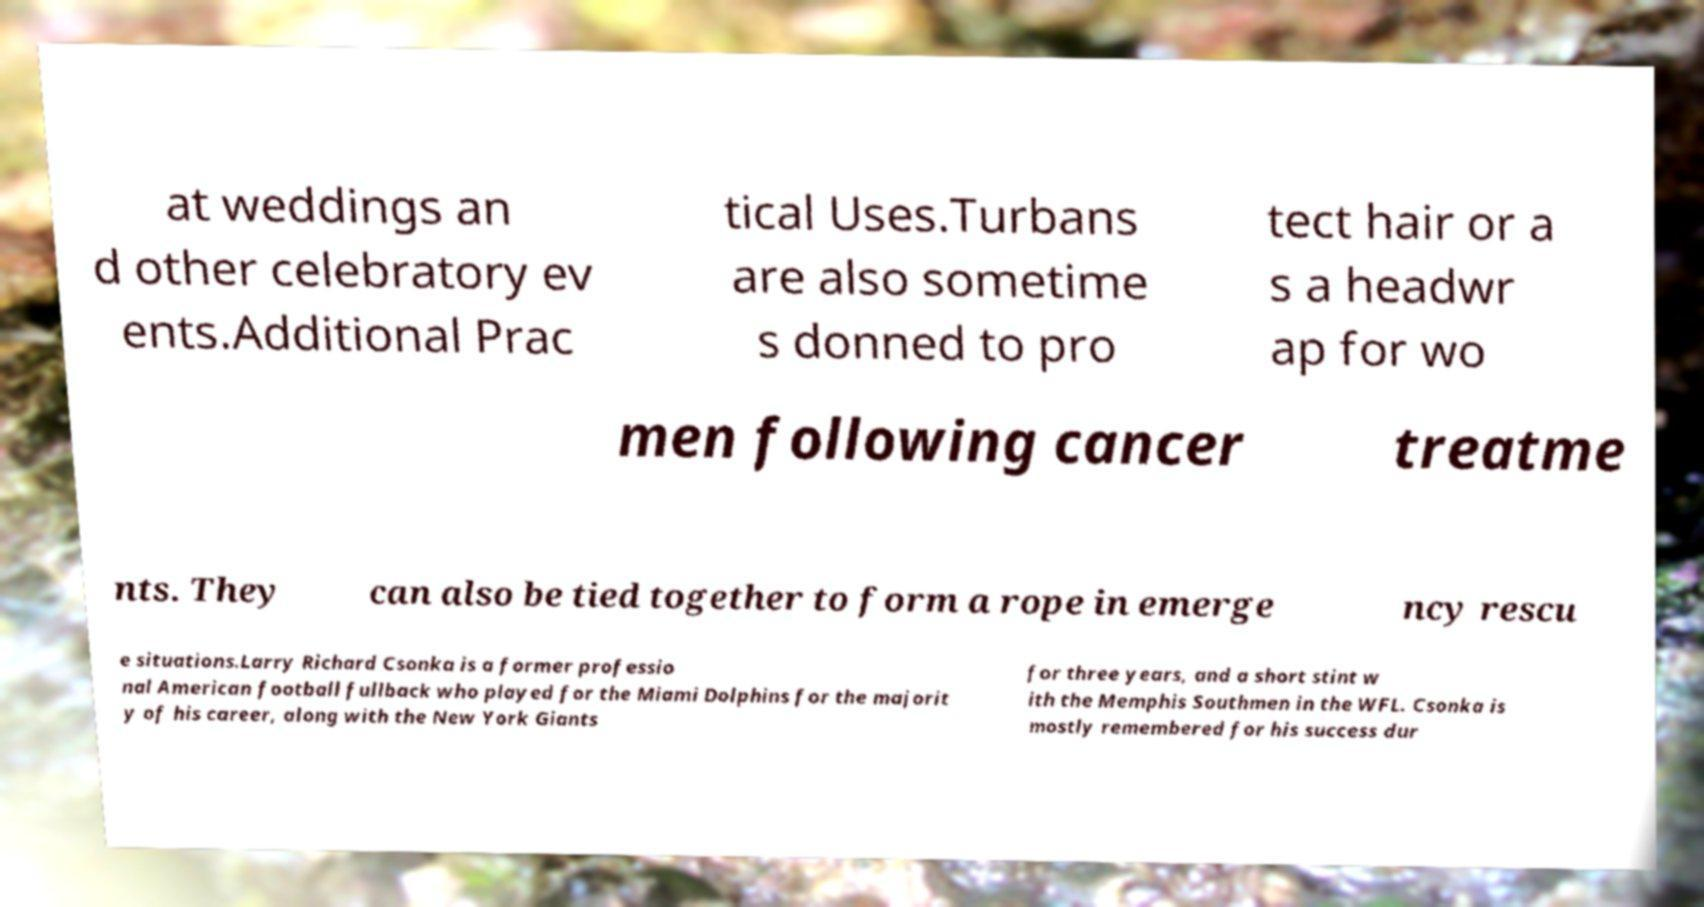Please identify and transcribe the text found in this image. at weddings an d other celebratory ev ents.Additional Prac tical Uses.Turbans are also sometime s donned to pro tect hair or a s a headwr ap for wo men following cancer treatme nts. They can also be tied together to form a rope in emerge ncy rescu e situations.Larry Richard Csonka is a former professio nal American football fullback who played for the Miami Dolphins for the majorit y of his career, along with the New York Giants for three years, and a short stint w ith the Memphis Southmen in the WFL. Csonka is mostly remembered for his success dur 